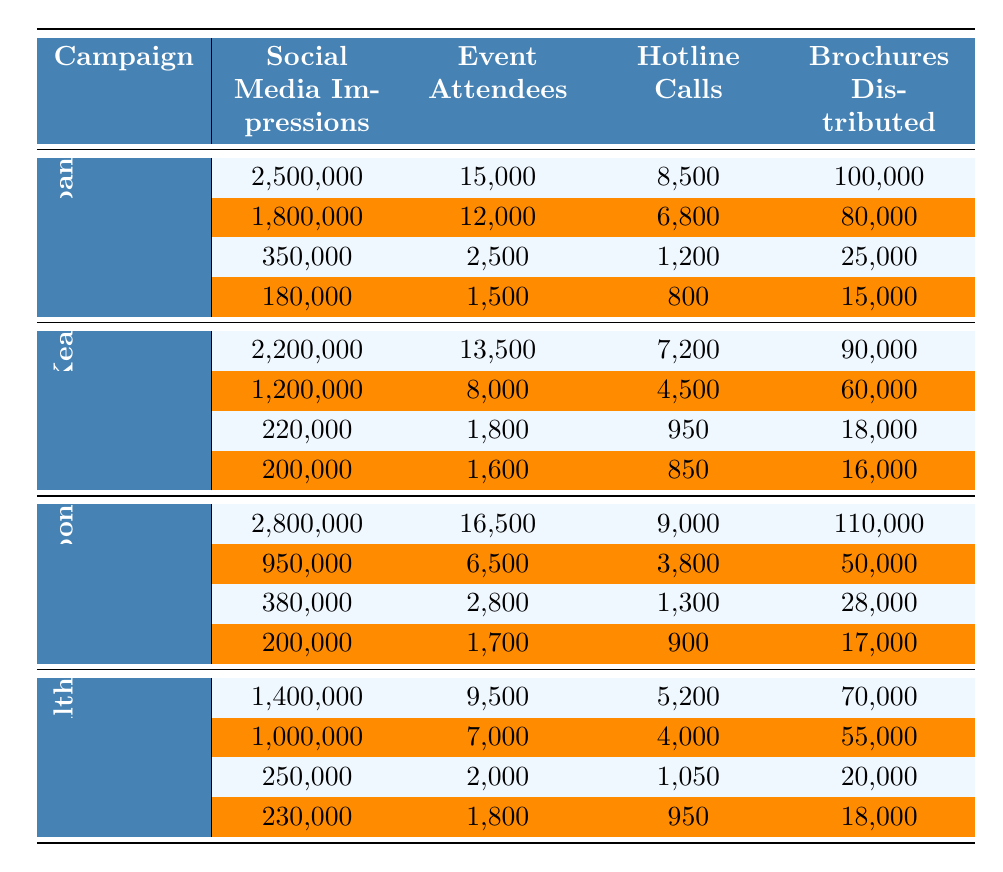What campaign had the highest number of social media impressions in Tokyo? Looking at the data for "Let's Talk Japan" and "Mind Matters Nippon" in Tokyo, "Mind Matters Nippon" had 2,800,000 social media impressions, which is higher than the 2,500,000 from "Let's Talk Japan".
Answer: Mind Matters Nippon Which campaign had the fewest event attendees in rural areas? In rural areas (Nara, Shimane, Tottori, and Akita Prefectures), "Kokoro no Kea" had the fewest event attendees, with 1,600 in Akita Prefecture and 1,800 in Tottori. Other rural campaigns had higher attendees.
Answer: Kokoro no Kea What is the total number of hotline calls for "Harmony for Health" across all locations? Adding the hotline calls: 5,200 (Fukuoka) + 4,000 (Sapporo) + 1,050 (Tottori) + 950 (Akita) results in 11,200 hotline calls in total for "Harmony for Health".
Answer: 11200 Did "Kokoro no Kea" have more brochure distributions than "Let's Talk Japan" in Osaka? In Osaka, "Kokoro no Kea" distributed 90,000 brochures while "Let's Talk Japan" distributed 80,000 brochures, so "Kokoro no Kea" did have more.
Answer: Yes What is the total reach through social media impressions for all campaigns in urban locations? The total social media impressions for urban locations (Tokyo, Osaka, Fukuoka, Sapporo) are: 2,500,000 + 1,800,000 + 1,400,000 + 1,000,000 + 2,800,000 + 2,200,000 + 1,200,000 + 950,000, which sums to 13,850,000.
Answer: 13850000 Which campaign had the highest average number of event attendees across all locations? Calculating the average attendees for each campaign: "Let's Talk Japan" has (15,000 + 12,000 + 2,500 + 1,500)/4 = 7,750; "Kokoro no Kea" has (13,500 + 8,000 + 1,800 + 1,600)/4 = 6,975; "Mind Matters Nippon" has (16,500 + 6,500 + 2,800 + 1,700)/4 = 6,875; "Harmony for Health" has (9,500 + 7,000 + 2,000 + 1,800)/4 = 5,075. "Let's Talk Japan" has the highest average at 7,750.
Answer: Let's Talk Japan How many more brochures were distributed by "Mind Matters Nippon" than "Kokoro no Kea" in total? The total brochures for "Mind Matters Nippon" are 110,000 + 50,000 + 28,000 + 17,000 = 205,000; for "Kokoro no Kea", they are 90,000 + 60,000 + 18,000 + 16,000 = 184,000. The difference is 205,000 - 184,000 = 21,000.
Answer: 21000 Which campaign consistently had the lowest numbers across all metrics in rural areas? Reviewing the data for rural areas, "Shimane Prefecture" shows low metrics consistently for all campaigns, particularly across hotline calls and event attendees, and thus indicates lower performance in rural outreach.
Answer: Harmony for Health 